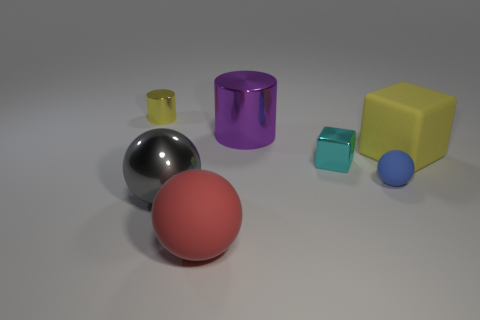There is a tiny object that is the same color as the rubber cube; what material is it?
Provide a short and direct response. Metal. Are there the same number of balls right of the shiny sphere and cyan things that are behind the cyan object?
Your response must be concise. No. There is a object that is in front of the large shiny sphere; what size is it?
Provide a short and direct response. Large. Are there any small purple cylinders that have the same material as the gray ball?
Provide a succinct answer. No. There is a sphere that is behind the metallic ball; is it the same color as the metallic cube?
Make the answer very short. No. Are there the same number of tiny metal objects on the right side of the big metal cylinder and large purple cylinders?
Offer a very short reply. Yes. Are there any other cylinders of the same color as the big cylinder?
Your answer should be very brief. No. Is the cyan cube the same size as the yellow shiny thing?
Keep it short and to the point. Yes. There is a purple thing that is on the left side of the sphere that is on the right side of the metal block; how big is it?
Your answer should be very brief. Large. There is a object that is both behind the big gray sphere and in front of the small cube; what size is it?
Give a very brief answer. Small. 